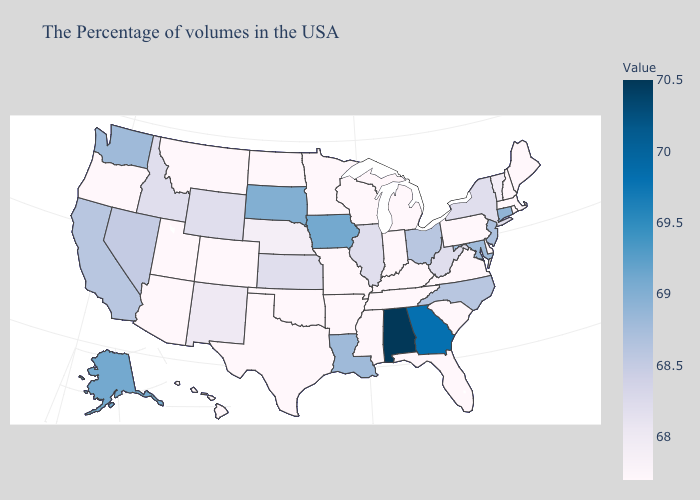Does Iowa have the highest value in the USA?
Give a very brief answer. No. Among the states that border Rhode Island , does Massachusetts have the highest value?
Keep it brief. No. Does Alabama have the highest value in the USA?
Short answer required. Yes. Which states have the highest value in the USA?
Keep it brief. Alabama. Which states have the highest value in the USA?
Quick response, please. Alabama. Among the states that border Utah , which have the highest value?
Concise answer only. Nevada. Among the states that border Florida , does Georgia have the lowest value?
Give a very brief answer. Yes. 